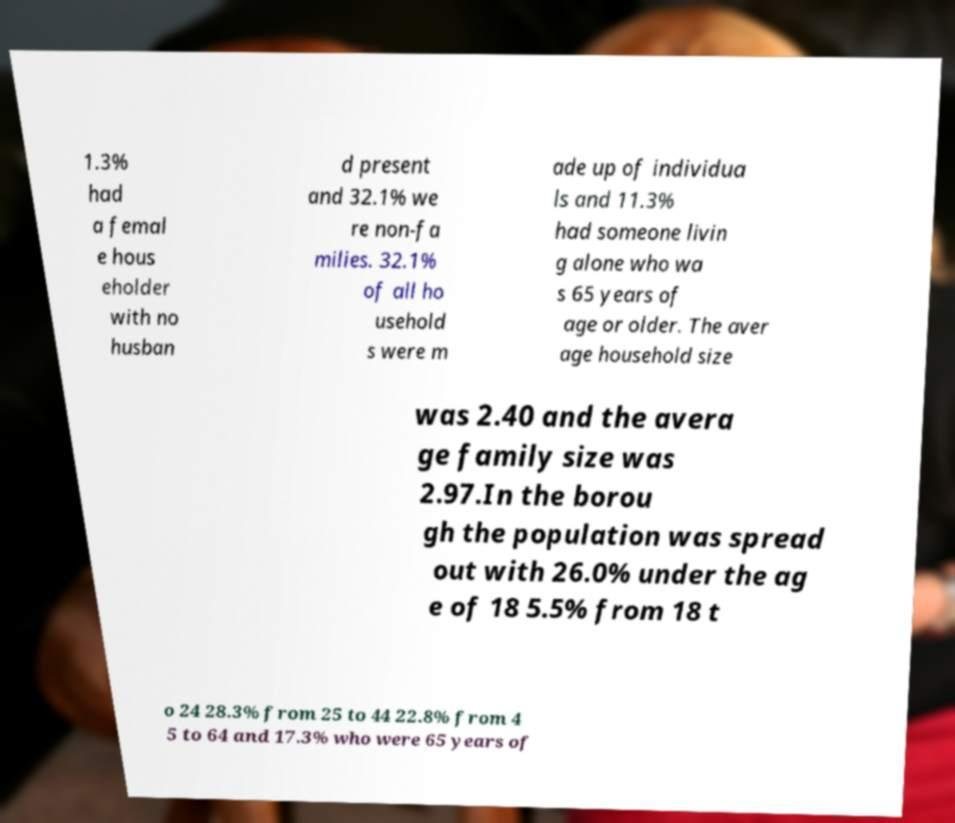There's text embedded in this image that I need extracted. Can you transcribe it verbatim? 1.3% had a femal e hous eholder with no husban d present and 32.1% we re non-fa milies. 32.1% of all ho usehold s were m ade up of individua ls and 11.3% had someone livin g alone who wa s 65 years of age or older. The aver age household size was 2.40 and the avera ge family size was 2.97.In the borou gh the population was spread out with 26.0% under the ag e of 18 5.5% from 18 t o 24 28.3% from 25 to 44 22.8% from 4 5 to 64 and 17.3% who were 65 years of 